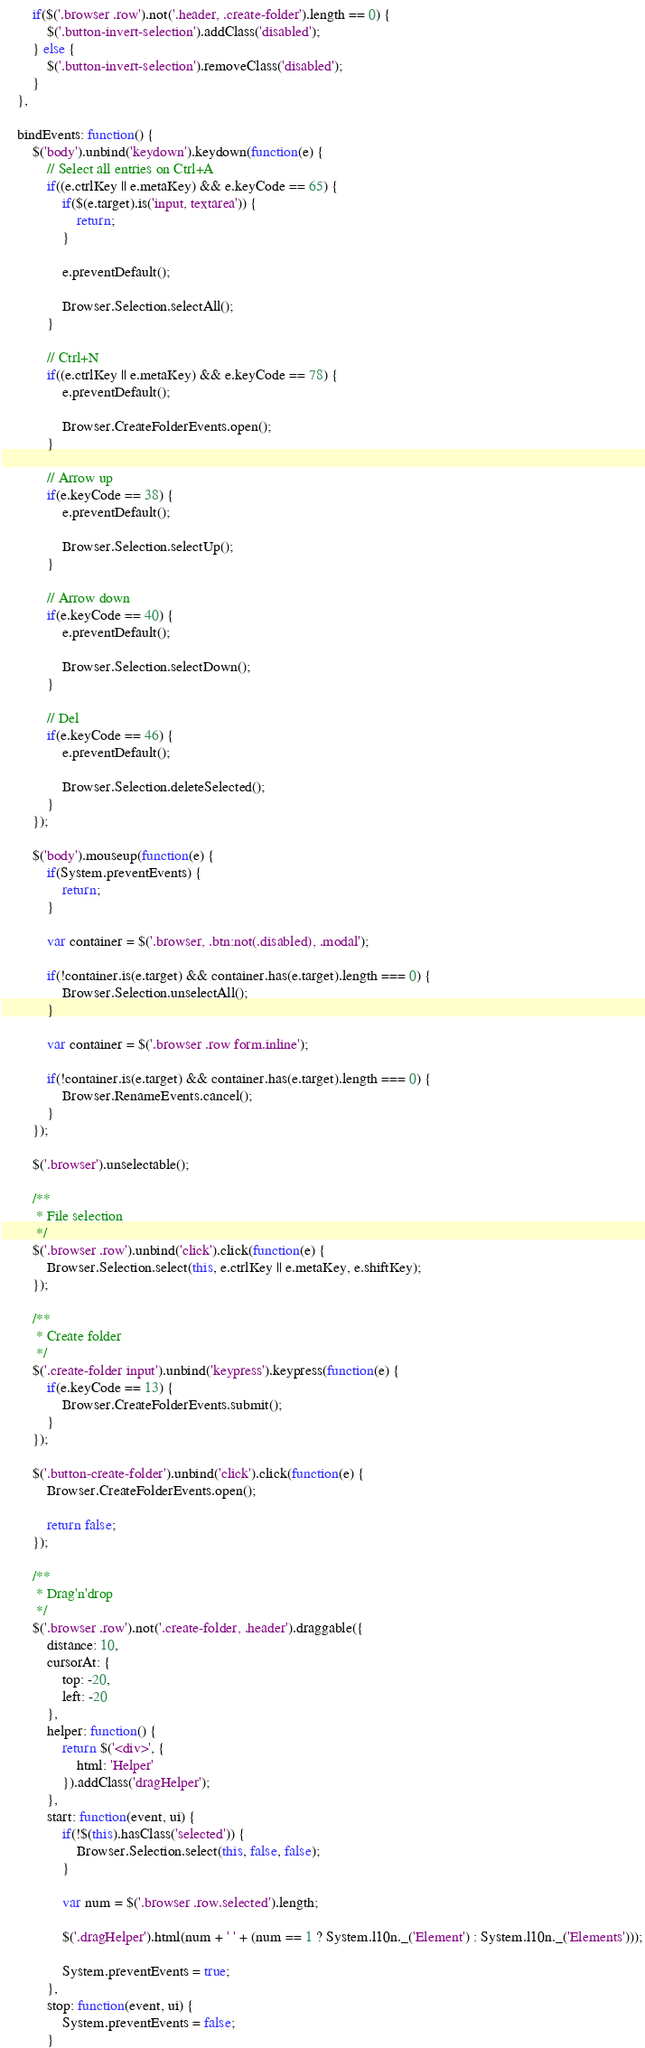Convert code to text. <code><loc_0><loc_0><loc_500><loc_500><_JavaScript_>		if($('.browser .row').not('.header, .create-folder').length == 0) {
			$('.button-invert-selection').addClass('disabled');
		} else {
			$('.button-invert-selection').removeClass('disabled');
		}
	},
	
	bindEvents: function() {
		$('body').unbind('keydown').keydown(function(e) {
			// Select all entries on Ctrl+A
			if((e.ctrlKey || e.metaKey) && e.keyCode == 65) {
				if($(e.target).is('input, textarea')) {
					return;	
				}
				
				e.preventDefault();
				
				Browser.Selection.selectAll();
			}
			
			// Ctrl+N
			if((e.ctrlKey || e.metaKey) && e.keyCode == 78) {
				e.preventDefault();
				
				Browser.CreateFolderEvents.open();	
			}
			
			// Arrow up
			if(e.keyCode == 38) {
				e.preventDefault();
				
				Browser.Selection.selectUp();	
			}
			
			// Arrow down
			if(e.keyCode == 40) {
				e.preventDefault();
				
				Browser.Selection.selectDown();	
			}
			
			// Del
			if(e.keyCode == 46) {
				e.preventDefault();
				
				Browser.Selection.deleteSelected();
			}
        });	
			
		$('body').mouseup(function(e) {
			if(System.preventEvents) {
				return;	
			}
		   
		    var container = $('.browser, .btn:not(.disabled), .modal');
			
			if(!container.is(e.target) && container.has(e.target).length === 0) {
				Browser.Selection.unselectAll();
			}
			
			var container = $('.browser .row form.inline');
			
			if(!container.is(e.target) && container.has(e.target).length === 0) {
				Browser.RenameEvents.cancel();
			}
        });
		
		$('.browser').unselectable();
		
		/**
		 * File selection
		 */
		$('.browser .row').unbind('click').click(function(e) {
			Browser.Selection.select(this, e.ctrlKey || e.metaKey, e.shiftKey);
		});
		
		/**
		 * Create folder
		 */
		$('.create-folder input').unbind('keypress').keypress(function(e) {
            if(e.keyCode == 13) {
				Browser.CreateFolderEvents.submit();
			}
        }); 
		
		$('.button-create-folder').unbind('click').click(function(e) {
            Browser.CreateFolderEvents.open();
						
			return false;
        });
		
		/**
		 * Drag'n'drop
		 */
		$('.browser .row').not('.create-folder, .header').draggable({
			distance: 10,			
			cursorAt: {
				top: -20,
				left: -20
			},
			helper: function() {
				return $('<div>', {
					html: 'Helper'
				}).addClass('dragHelper');
			},
			start: function(event, ui) {
				if(!$(this).hasClass('selected')) {
					Browser.Selection.select(this, false, false);	
				}
				
				var num = $('.browser .row.selected').length;
								
				$('.dragHelper').html(num + ' ' + (num == 1 ? System.l10n._('Element') : System.l10n._('Elements')));
				
				System.preventEvents = true;
			},
			stop: function(event, ui) {
				System.preventEvents = false;
			}</code> 